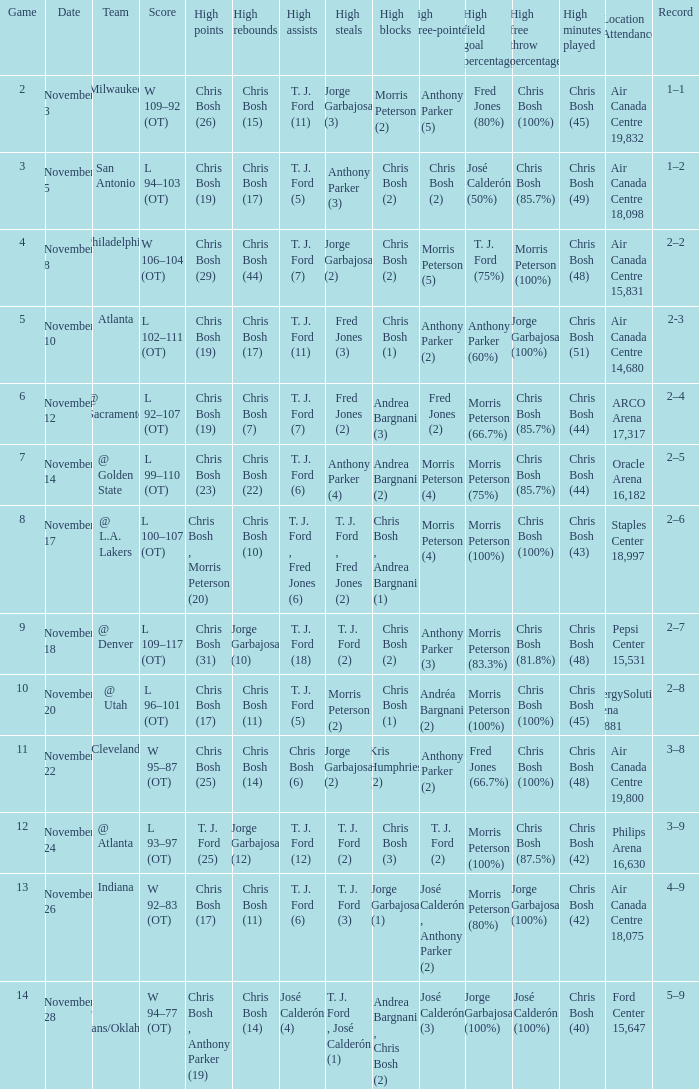What was the score of the game on November 12? L 92–107 (OT). 